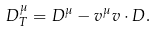Convert formula to latex. <formula><loc_0><loc_0><loc_500><loc_500>D _ { T } ^ { \mu } = D ^ { \mu } - v ^ { \mu } v \cdot D .</formula> 